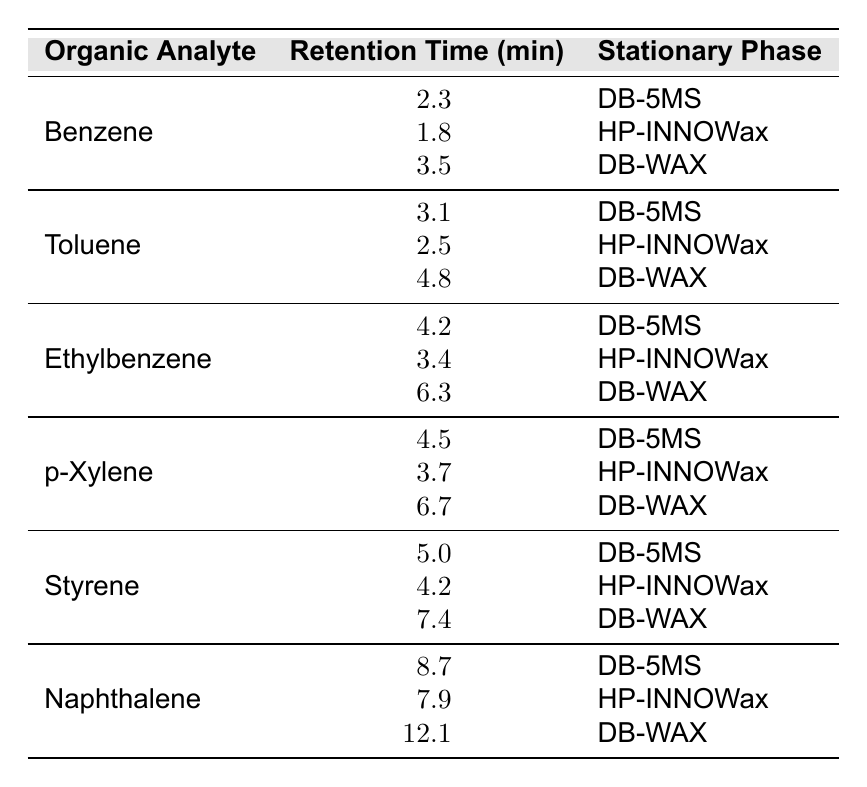What is the retention time of Toluene using the DB-5MS stationary phase? By locating Toluene in the table under the DB-5MS section, we find that its retention time is 3.1 minutes.
Answer: 3.1 minutes Which stationary phase gives the longest retention time for Naphthalene? Looking at the retention times of Naphthalene across all three stationary phases, we see that 12.1 minutes is the highest, which corresponds to the DB-WAX phase.
Answer: DB-WAX What is the average retention time of Ethylbenzene across all stationary phases? Summing the retention times for Ethylbenzene: 4.2 (DB-5MS) + 3.4 (HP-INNOWax) + 6.3 (DB-WAX) equals 14. The average retention time is then 14 divided by 3, which equals approximately 4.67.
Answer: 4.67 minutes Is the retention time for Benzene in HP-INNOWax less than that in DB-WAX? The retention time for Benzene in HP-INNOWax is 1.8 minutes and the retention time in DB-WAX is 3.5 minutes. Since 1.8 is less than 3.5, this statement is true.
Answer: Yes Which analyte shows the smallest difference in retention time between HP-INNOWax and DB-WAX? The differences for each analyte are: Benzene: 1.8 - 3.5 = 1.7, Toluene: 2.5 - 4.8 = 2.3, Ethylbenzene: 3.4 - 6.3 = 2.9, p-Xylene: 3.7 - 6.7 = 3.0, Styrene: 4.2 - 7.4 = 3.2, Naphthalene: 7.9 - 12.1 = 4.2. The smallest difference is 1.7 for Benzene.
Answer: Benzene What percentage increase in retention time does Styrene have when switching from DB-5MS to DB-WAX? The retention time for Styrene in DB-5MS is 5.0 minutes and in DB-WAX is 7.4 minutes. The increase is 7.4 - 5.0 = 2.4 minutes. The percentage increase is (2.4/5.0) * 100 = 48%.
Answer: 48% Which analyte has the highest retention time in the table? By comparing all retention times listed, Naphthalene in DB-WAX has the highest value at 12.1 minutes, thus it is the highest overall.
Answer: Naphthalene Are there any organic analytes with the same retention time in different stationary phases? Checking the retention times, no two analytes have the same retention time across different phases; thus, there are no duplicates.
Answer: No 